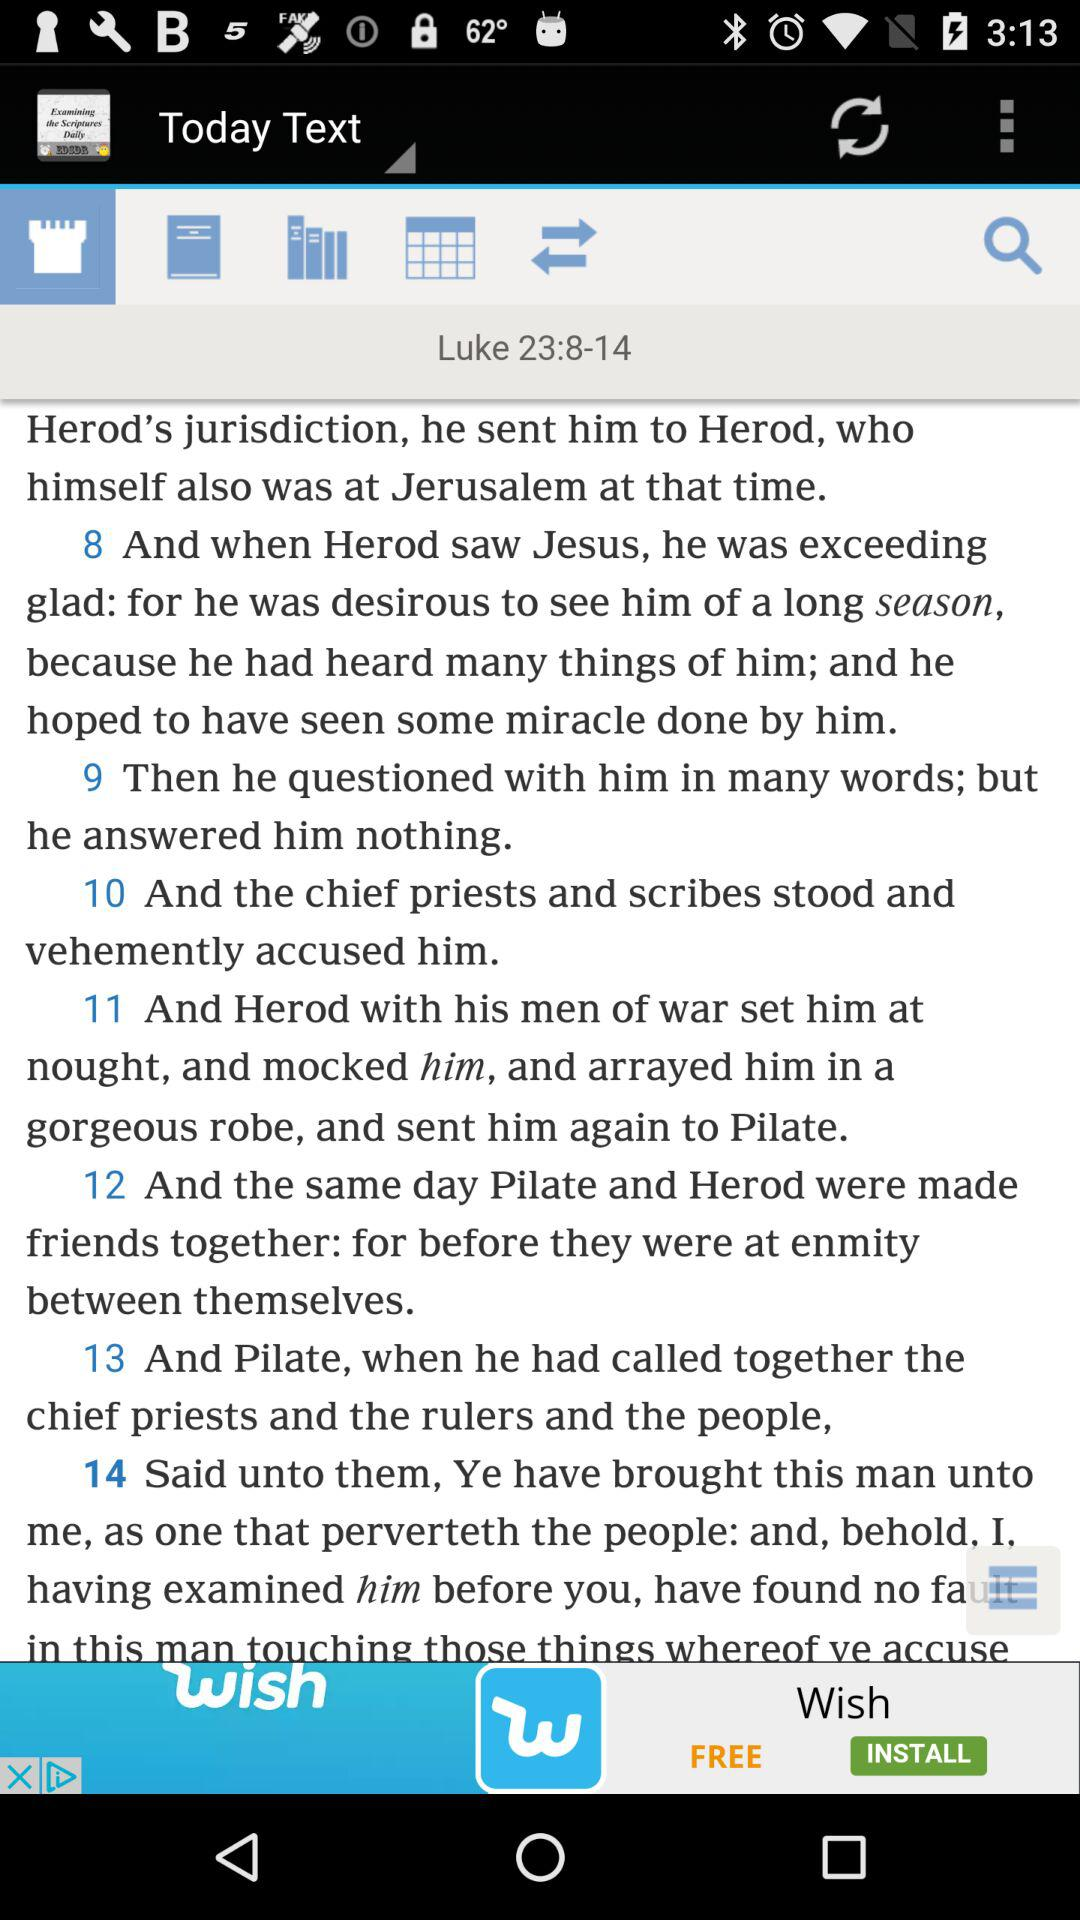What is the given date?
When the provided information is insufficient, respond with <no answer>. <no answer> 